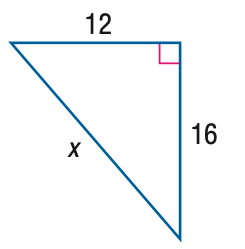Answer the mathemtical geometry problem and directly provide the correct option letter.
Question: Find x.
Choices: A: 18 B: 20 C: 22 D: 24 B 